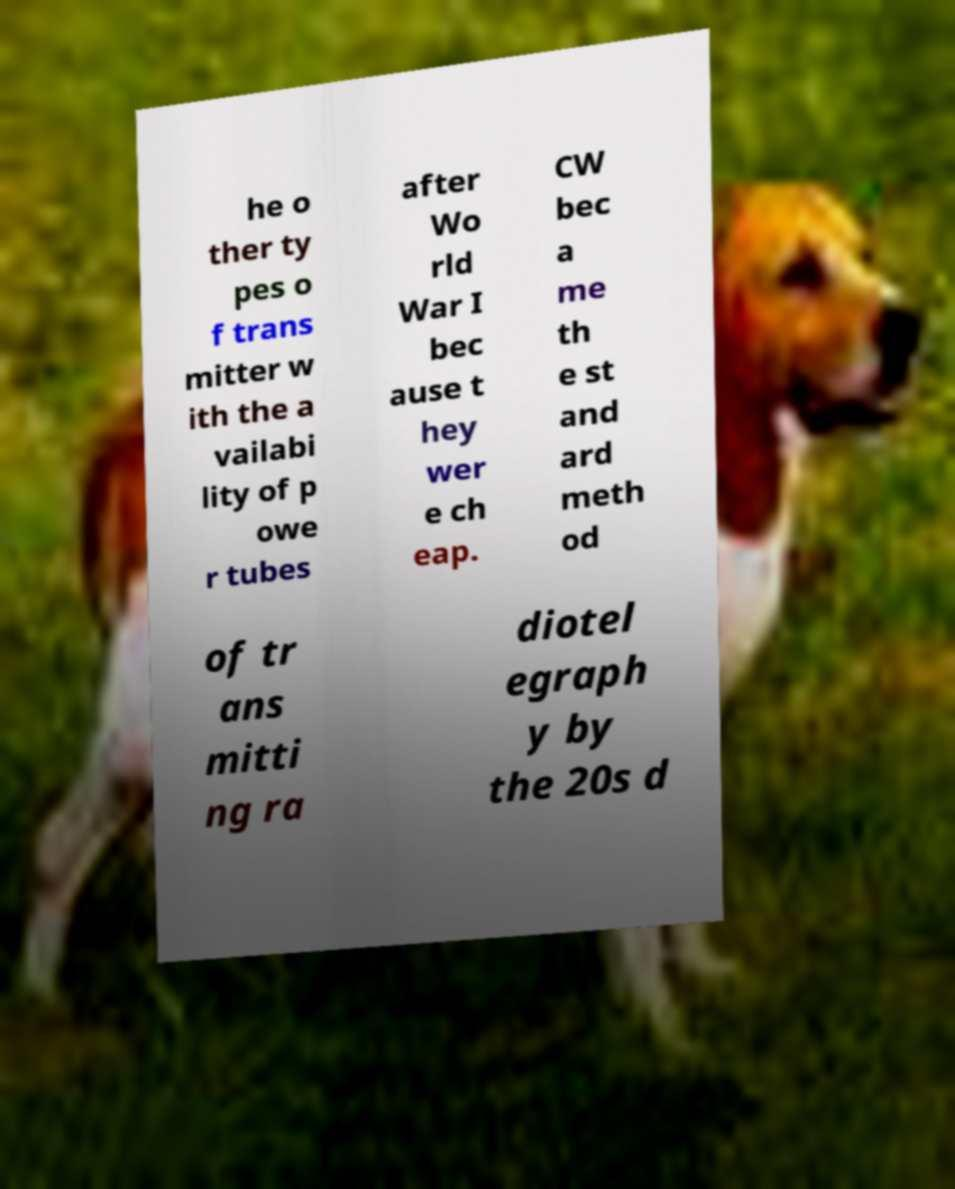For documentation purposes, I need the text within this image transcribed. Could you provide that? he o ther ty pes o f trans mitter w ith the a vailabi lity of p owe r tubes after Wo rld War I bec ause t hey wer e ch eap. CW bec a me th e st and ard meth od of tr ans mitti ng ra diotel egraph y by the 20s d 